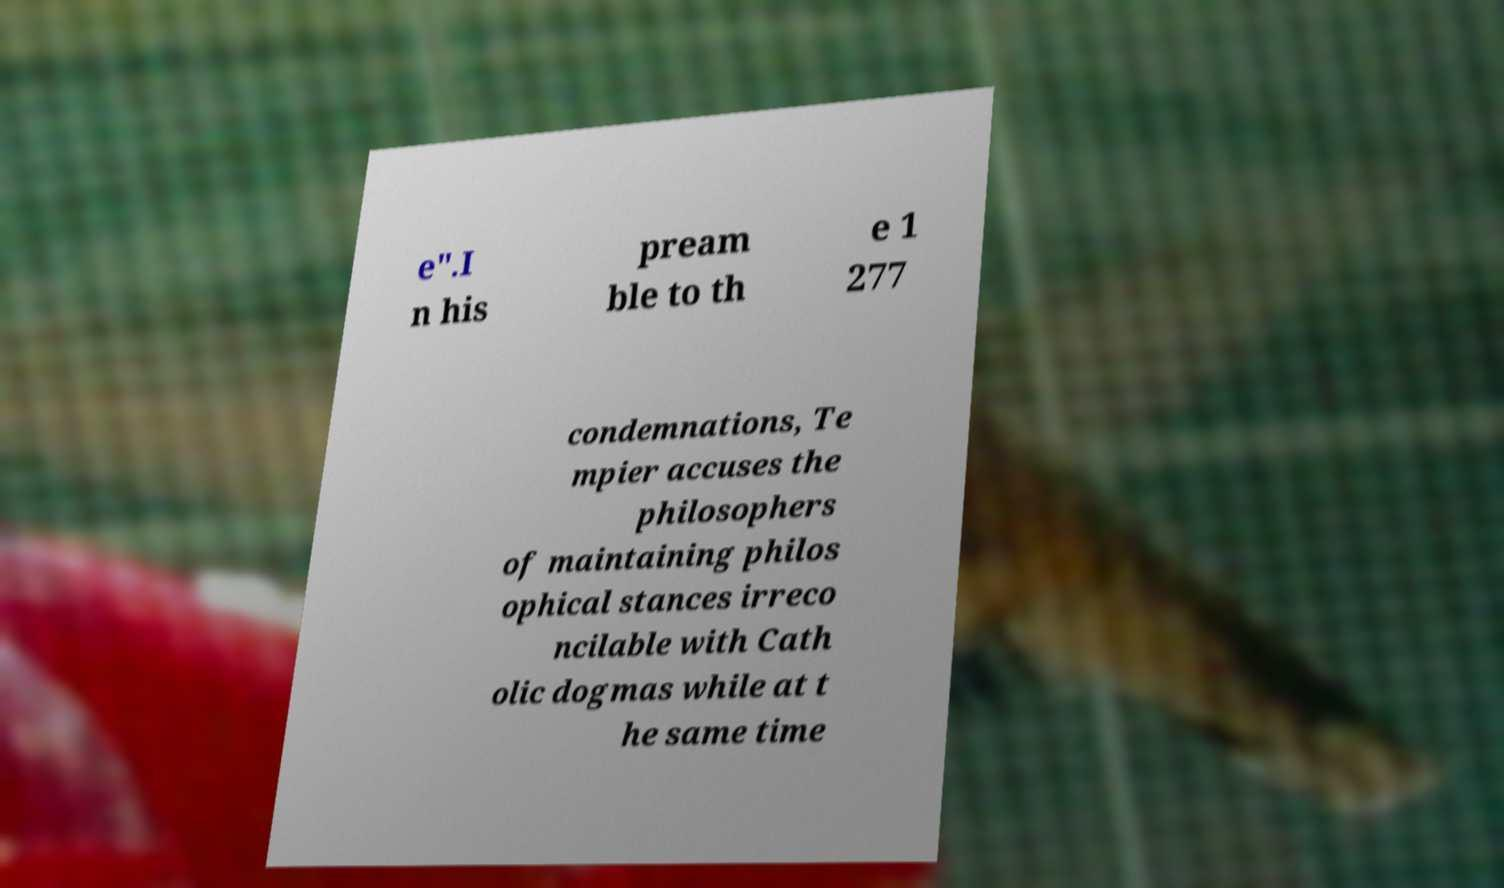What messages or text are displayed in this image? I need them in a readable, typed format. e".I n his pream ble to th e 1 277 condemnations, Te mpier accuses the philosophers of maintaining philos ophical stances irreco ncilable with Cath olic dogmas while at t he same time 